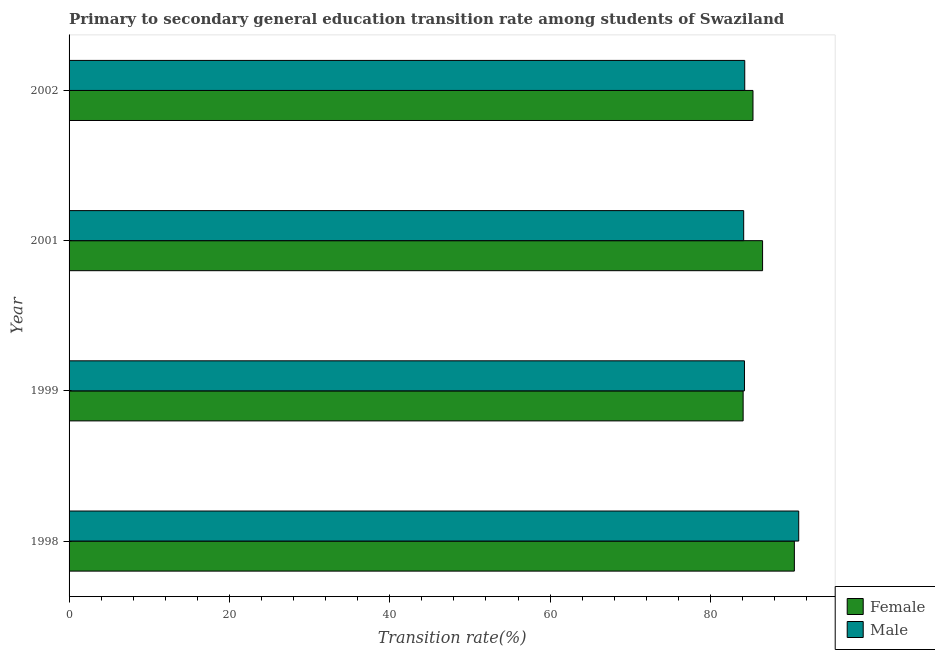Are the number of bars on each tick of the Y-axis equal?
Offer a terse response. Yes. How many bars are there on the 2nd tick from the bottom?
Provide a short and direct response. 2. What is the label of the 4th group of bars from the top?
Offer a very short reply. 1998. In how many cases, is the number of bars for a given year not equal to the number of legend labels?
Provide a succinct answer. 0. What is the transition rate among male students in 2001?
Make the answer very short. 84.15. Across all years, what is the maximum transition rate among female students?
Ensure brevity in your answer.  90.47. Across all years, what is the minimum transition rate among female students?
Make the answer very short. 84.08. What is the total transition rate among female students in the graph?
Offer a very short reply. 346.36. What is the difference between the transition rate among male students in 1999 and that in 2001?
Keep it short and to the point. 0.1. What is the difference between the transition rate among male students in 2002 and the transition rate among female students in 2001?
Offer a terse response. -2.22. What is the average transition rate among male students per year?
Make the answer very short. 85.92. In the year 1999, what is the difference between the transition rate among female students and transition rate among male students?
Your answer should be very brief. -0.17. What is the ratio of the transition rate among female students in 1998 to that in 2002?
Keep it short and to the point. 1.06. Is the transition rate among female students in 1998 less than that in 2001?
Offer a very short reply. No. What is the difference between the highest and the second highest transition rate among female students?
Ensure brevity in your answer.  3.96. What is the difference between the highest and the lowest transition rate among female students?
Your answer should be very brief. 6.39. Is the sum of the transition rate among female students in 1998 and 1999 greater than the maximum transition rate among male students across all years?
Make the answer very short. Yes. What does the 1st bar from the top in 2002 represents?
Provide a short and direct response. Male. What does the 1st bar from the bottom in 1999 represents?
Provide a succinct answer. Female. How many bars are there?
Keep it short and to the point. 8. Are all the bars in the graph horizontal?
Your answer should be compact. Yes. How many years are there in the graph?
Offer a very short reply. 4. What is the difference between two consecutive major ticks on the X-axis?
Offer a very short reply. 20. Are the values on the major ticks of X-axis written in scientific E-notation?
Your answer should be compact. No. Does the graph contain any zero values?
Make the answer very short. No. Does the graph contain grids?
Provide a succinct answer. No. Where does the legend appear in the graph?
Offer a terse response. Bottom right. How many legend labels are there?
Offer a terse response. 2. What is the title of the graph?
Provide a succinct answer. Primary to secondary general education transition rate among students of Swaziland. What is the label or title of the X-axis?
Your response must be concise. Transition rate(%). What is the Transition rate(%) in Female in 1998?
Make the answer very short. 90.47. What is the Transition rate(%) of Male in 1998?
Your answer should be compact. 91.01. What is the Transition rate(%) of Female in 1999?
Provide a short and direct response. 84.08. What is the Transition rate(%) of Male in 1999?
Make the answer very short. 84.25. What is the Transition rate(%) in Female in 2001?
Make the answer very short. 86.51. What is the Transition rate(%) of Male in 2001?
Ensure brevity in your answer.  84.15. What is the Transition rate(%) in Female in 2002?
Offer a very short reply. 85.31. What is the Transition rate(%) in Male in 2002?
Make the answer very short. 84.28. Across all years, what is the maximum Transition rate(%) in Female?
Ensure brevity in your answer.  90.47. Across all years, what is the maximum Transition rate(%) in Male?
Your response must be concise. 91.01. Across all years, what is the minimum Transition rate(%) in Female?
Ensure brevity in your answer.  84.08. Across all years, what is the minimum Transition rate(%) of Male?
Provide a short and direct response. 84.15. What is the total Transition rate(%) in Female in the graph?
Keep it short and to the point. 346.36. What is the total Transition rate(%) of Male in the graph?
Your response must be concise. 343.69. What is the difference between the Transition rate(%) of Female in 1998 and that in 1999?
Make the answer very short. 6.39. What is the difference between the Transition rate(%) of Male in 1998 and that in 1999?
Your answer should be compact. 6.77. What is the difference between the Transition rate(%) of Female in 1998 and that in 2001?
Offer a very short reply. 3.96. What is the difference between the Transition rate(%) in Male in 1998 and that in 2001?
Ensure brevity in your answer.  6.86. What is the difference between the Transition rate(%) in Female in 1998 and that in 2002?
Provide a succinct answer. 5.16. What is the difference between the Transition rate(%) of Male in 1998 and that in 2002?
Give a very brief answer. 6.73. What is the difference between the Transition rate(%) of Female in 1999 and that in 2001?
Your answer should be very brief. -2.43. What is the difference between the Transition rate(%) of Male in 1999 and that in 2001?
Offer a very short reply. 0.1. What is the difference between the Transition rate(%) in Female in 1999 and that in 2002?
Give a very brief answer. -1.23. What is the difference between the Transition rate(%) of Male in 1999 and that in 2002?
Offer a terse response. -0.03. What is the difference between the Transition rate(%) of Female in 2001 and that in 2002?
Provide a succinct answer. 1.2. What is the difference between the Transition rate(%) of Male in 2001 and that in 2002?
Keep it short and to the point. -0.13. What is the difference between the Transition rate(%) in Female in 1998 and the Transition rate(%) in Male in 1999?
Provide a short and direct response. 6.22. What is the difference between the Transition rate(%) of Female in 1998 and the Transition rate(%) of Male in 2001?
Your response must be concise. 6.32. What is the difference between the Transition rate(%) in Female in 1998 and the Transition rate(%) in Male in 2002?
Your answer should be compact. 6.19. What is the difference between the Transition rate(%) of Female in 1999 and the Transition rate(%) of Male in 2001?
Give a very brief answer. -0.07. What is the difference between the Transition rate(%) of Female in 1999 and the Transition rate(%) of Male in 2002?
Your response must be concise. -0.2. What is the difference between the Transition rate(%) in Female in 2001 and the Transition rate(%) in Male in 2002?
Provide a short and direct response. 2.23. What is the average Transition rate(%) in Female per year?
Your response must be concise. 86.59. What is the average Transition rate(%) of Male per year?
Keep it short and to the point. 85.92. In the year 1998, what is the difference between the Transition rate(%) in Female and Transition rate(%) in Male?
Provide a short and direct response. -0.54. In the year 1999, what is the difference between the Transition rate(%) in Female and Transition rate(%) in Male?
Ensure brevity in your answer.  -0.17. In the year 2001, what is the difference between the Transition rate(%) in Female and Transition rate(%) in Male?
Ensure brevity in your answer.  2.36. In the year 2002, what is the difference between the Transition rate(%) in Female and Transition rate(%) in Male?
Give a very brief answer. 1.03. What is the ratio of the Transition rate(%) in Female in 1998 to that in 1999?
Your answer should be compact. 1.08. What is the ratio of the Transition rate(%) in Male in 1998 to that in 1999?
Your response must be concise. 1.08. What is the ratio of the Transition rate(%) in Female in 1998 to that in 2001?
Give a very brief answer. 1.05. What is the ratio of the Transition rate(%) of Male in 1998 to that in 2001?
Your response must be concise. 1.08. What is the ratio of the Transition rate(%) in Female in 1998 to that in 2002?
Give a very brief answer. 1.06. What is the ratio of the Transition rate(%) in Male in 1998 to that in 2002?
Your answer should be very brief. 1.08. What is the ratio of the Transition rate(%) of Female in 1999 to that in 2001?
Offer a very short reply. 0.97. What is the ratio of the Transition rate(%) in Female in 1999 to that in 2002?
Make the answer very short. 0.99. What is the ratio of the Transition rate(%) of Female in 2001 to that in 2002?
Provide a short and direct response. 1.01. What is the ratio of the Transition rate(%) in Male in 2001 to that in 2002?
Keep it short and to the point. 1. What is the difference between the highest and the second highest Transition rate(%) of Female?
Offer a terse response. 3.96. What is the difference between the highest and the second highest Transition rate(%) of Male?
Make the answer very short. 6.73. What is the difference between the highest and the lowest Transition rate(%) in Female?
Offer a terse response. 6.39. What is the difference between the highest and the lowest Transition rate(%) of Male?
Your response must be concise. 6.86. 